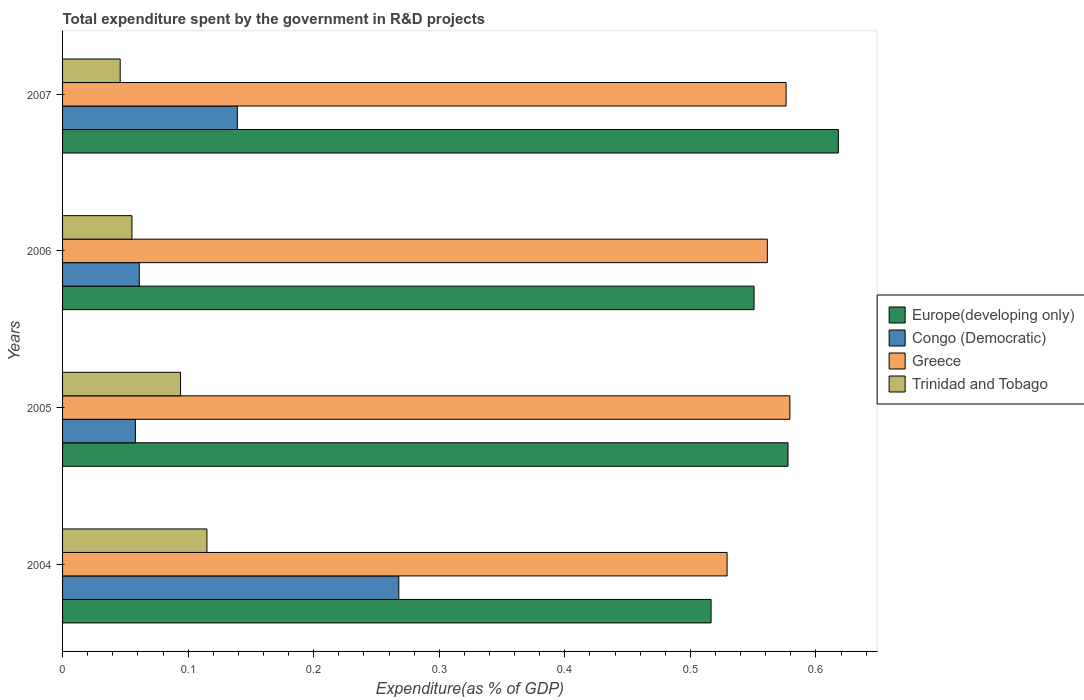How many groups of bars are there?
Make the answer very short. 4. Are the number of bars on each tick of the Y-axis equal?
Your answer should be very brief. Yes. How many bars are there on the 3rd tick from the top?
Make the answer very short. 4. What is the label of the 4th group of bars from the top?
Make the answer very short. 2004. In how many cases, is the number of bars for a given year not equal to the number of legend labels?
Keep it short and to the point. 0. What is the total expenditure spent by the government in R&D projects in Europe(developing only) in 2006?
Your answer should be very brief. 0.55. Across all years, what is the maximum total expenditure spent by the government in R&D projects in Europe(developing only)?
Provide a succinct answer. 0.62. Across all years, what is the minimum total expenditure spent by the government in R&D projects in Trinidad and Tobago?
Offer a very short reply. 0.05. In which year was the total expenditure spent by the government in R&D projects in Trinidad and Tobago maximum?
Ensure brevity in your answer.  2004. What is the total total expenditure spent by the government in R&D projects in Trinidad and Tobago in the graph?
Give a very brief answer. 0.31. What is the difference between the total expenditure spent by the government in R&D projects in Congo (Democratic) in 2005 and that in 2006?
Offer a very short reply. -0. What is the difference between the total expenditure spent by the government in R&D projects in Congo (Democratic) in 2005 and the total expenditure spent by the government in R&D projects in Europe(developing only) in 2007?
Offer a very short reply. -0.56. What is the average total expenditure spent by the government in R&D projects in Europe(developing only) per year?
Ensure brevity in your answer.  0.57. In the year 2007, what is the difference between the total expenditure spent by the government in R&D projects in Trinidad and Tobago and total expenditure spent by the government in R&D projects in Greece?
Offer a very short reply. -0.53. In how many years, is the total expenditure spent by the government in R&D projects in Congo (Democratic) greater than 0.1 %?
Ensure brevity in your answer.  2. What is the ratio of the total expenditure spent by the government in R&D projects in Europe(developing only) in 2006 to that in 2007?
Keep it short and to the point. 0.89. Is the total expenditure spent by the government in R&D projects in Greece in 2004 less than that in 2007?
Your answer should be very brief. Yes. Is the difference between the total expenditure spent by the government in R&D projects in Trinidad and Tobago in 2004 and 2007 greater than the difference between the total expenditure spent by the government in R&D projects in Greece in 2004 and 2007?
Your answer should be compact. Yes. What is the difference between the highest and the second highest total expenditure spent by the government in R&D projects in Europe(developing only)?
Ensure brevity in your answer.  0.04. What is the difference between the highest and the lowest total expenditure spent by the government in R&D projects in Congo (Democratic)?
Offer a terse response. 0.21. In how many years, is the total expenditure spent by the government in R&D projects in Greece greater than the average total expenditure spent by the government in R&D projects in Greece taken over all years?
Give a very brief answer. 2. Is it the case that in every year, the sum of the total expenditure spent by the government in R&D projects in Congo (Democratic) and total expenditure spent by the government in R&D projects in Greece is greater than the total expenditure spent by the government in R&D projects in Trinidad and Tobago?
Make the answer very short. Yes. How many bars are there?
Your answer should be very brief. 16. How many years are there in the graph?
Provide a succinct answer. 4. What is the difference between two consecutive major ticks on the X-axis?
Offer a terse response. 0.1. Are the values on the major ticks of X-axis written in scientific E-notation?
Provide a short and direct response. No. Does the graph contain any zero values?
Offer a very short reply. No. Does the graph contain grids?
Offer a terse response. No. Where does the legend appear in the graph?
Make the answer very short. Center right. What is the title of the graph?
Offer a very short reply. Total expenditure spent by the government in R&D projects. What is the label or title of the X-axis?
Give a very brief answer. Expenditure(as % of GDP). What is the label or title of the Y-axis?
Your answer should be compact. Years. What is the Expenditure(as % of GDP) in Europe(developing only) in 2004?
Provide a succinct answer. 0.52. What is the Expenditure(as % of GDP) in Congo (Democratic) in 2004?
Provide a succinct answer. 0.27. What is the Expenditure(as % of GDP) of Greece in 2004?
Make the answer very short. 0.53. What is the Expenditure(as % of GDP) of Trinidad and Tobago in 2004?
Provide a succinct answer. 0.11. What is the Expenditure(as % of GDP) in Europe(developing only) in 2005?
Your answer should be very brief. 0.58. What is the Expenditure(as % of GDP) in Congo (Democratic) in 2005?
Provide a succinct answer. 0.06. What is the Expenditure(as % of GDP) of Greece in 2005?
Provide a short and direct response. 0.58. What is the Expenditure(as % of GDP) of Trinidad and Tobago in 2005?
Ensure brevity in your answer.  0.09. What is the Expenditure(as % of GDP) of Europe(developing only) in 2006?
Give a very brief answer. 0.55. What is the Expenditure(as % of GDP) of Congo (Democratic) in 2006?
Your answer should be compact. 0.06. What is the Expenditure(as % of GDP) of Greece in 2006?
Keep it short and to the point. 0.56. What is the Expenditure(as % of GDP) in Trinidad and Tobago in 2006?
Offer a very short reply. 0.06. What is the Expenditure(as % of GDP) of Europe(developing only) in 2007?
Keep it short and to the point. 0.62. What is the Expenditure(as % of GDP) in Congo (Democratic) in 2007?
Your response must be concise. 0.14. What is the Expenditure(as % of GDP) of Greece in 2007?
Your answer should be compact. 0.58. What is the Expenditure(as % of GDP) in Trinidad and Tobago in 2007?
Your answer should be very brief. 0.05. Across all years, what is the maximum Expenditure(as % of GDP) in Europe(developing only)?
Your answer should be compact. 0.62. Across all years, what is the maximum Expenditure(as % of GDP) in Congo (Democratic)?
Offer a very short reply. 0.27. Across all years, what is the maximum Expenditure(as % of GDP) of Greece?
Offer a terse response. 0.58. Across all years, what is the maximum Expenditure(as % of GDP) in Trinidad and Tobago?
Keep it short and to the point. 0.11. Across all years, what is the minimum Expenditure(as % of GDP) of Europe(developing only)?
Your answer should be compact. 0.52. Across all years, what is the minimum Expenditure(as % of GDP) in Congo (Democratic)?
Provide a succinct answer. 0.06. Across all years, what is the minimum Expenditure(as % of GDP) in Greece?
Your answer should be compact. 0.53. Across all years, what is the minimum Expenditure(as % of GDP) of Trinidad and Tobago?
Offer a very short reply. 0.05. What is the total Expenditure(as % of GDP) in Europe(developing only) in the graph?
Your answer should be compact. 2.26. What is the total Expenditure(as % of GDP) in Congo (Democratic) in the graph?
Keep it short and to the point. 0.53. What is the total Expenditure(as % of GDP) of Greece in the graph?
Offer a terse response. 2.25. What is the total Expenditure(as % of GDP) in Trinidad and Tobago in the graph?
Your answer should be very brief. 0.31. What is the difference between the Expenditure(as % of GDP) in Europe(developing only) in 2004 and that in 2005?
Provide a succinct answer. -0.06. What is the difference between the Expenditure(as % of GDP) in Congo (Democratic) in 2004 and that in 2005?
Keep it short and to the point. 0.21. What is the difference between the Expenditure(as % of GDP) in Trinidad and Tobago in 2004 and that in 2005?
Your response must be concise. 0.02. What is the difference between the Expenditure(as % of GDP) in Europe(developing only) in 2004 and that in 2006?
Keep it short and to the point. -0.03. What is the difference between the Expenditure(as % of GDP) in Congo (Democratic) in 2004 and that in 2006?
Make the answer very short. 0.21. What is the difference between the Expenditure(as % of GDP) of Greece in 2004 and that in 2006?
Offer a terse response. -0.03. What is the difference between the Expenditure(as % of GDP) of Trinidad and Tobago in 2004 and that in 2006?
Make the answer very short. 0.06. What is the difference between the Expenditure(as % of GDP) of Europe(developing only) in 2004 and that in 2007?
Keep it short and to the point. -0.1. What is the difference between the Expenditure(as % of GDP) in Congo (Democratic) in 2004 and that in 2007?
Your response must be concise. 0.13. What is the difference between the Expenditure(as % of GDP) in Greece in 2004 and that in 2007?
Offer a very short reply. -0.05. What is the difference between the Expenditure(as % of GDP) of Trinidad and Tobago in 2004 and that in 2007?
Make the answer very short. 0.07. What is the difference between the Expenditure(as % of GDP) in Europe(developing only) in 2005 and that in 2006?
Give a very brief answer. 0.03. What is the difference between the Expenditure(as % of GDP) of Congo (Democratic) in 2005 and that in 2006?
Your answer should be very brief. -0. What is the difference between the Expenditure(as % of GDP) in Greece in 2005 and that in 2006?
Keep it short and to the point. 0.02. What is the difference between the Expenditure(as % of GDP) of Trinidad and Tobago in 2005 and that in 2006?
Your response must be concise. 0.04. What is the difference between the Expenditure(as % of GDP) of Europe(developing only) in 2005 and that in 2007?
Your answer should be compact. -0.04. What is the difference between the Expenditure(as % of GDP) in Congo (Democratic) in 2005 and that in 2007?
Give a very brief answer. -0.08. What is the difference between the Expenditure(as % of GDP) in Greece in 2005 and that in 2007?
Offer a terse response. 0. What is the difference between the Expenditure(as % of GDP) in Trinidad and Tobago in 2005 and that in 2007?
Your response must be concise. 0.05. What is the difference between the Expenditure(as % of GDP) of Europe(developing only) in 2006 and that in 2007?
Your response must be concise. -0.07. What is the difference between the Expenditure(as % of GDP) in Congo (Democratic) in 2006 and that in 2007?
Provide a succinct answer. -0.08. What is the difference between the Expenditure(as % of GDP) of Greece in 2006 and that in 2007?
Give a very brief answer. -0.01. What is the difference between the Expenditure(as % of GDP) of Trinidad and Tobago in 2006 and that in 2007?
Offer a terse response. 0.01. What is the difference between the Expenditure(as % of GDP) of Europe(developing only) in 2004 and the Expenditure(as % of GDP) of Congo (Democratic) in 2005?
Keep it short and to the point. 0.46. What is the difference between the Expenditure(as % of GDP) in Europe(developing only) in 2004 and the Expenditure(as % of GDP) in Greece in 2005?
Make the answer very short. -0.06. What is the difference between the Expenditure(as % of GDP) of Europe(developing only) in 2004 and the Expenditure(as % of GDP) of Trinidad and Tobago in 2005?
Give a very brief answer. 0.42. What is the difference between the Expenditure(as % of GDP) of Congo (Democratic) in 2004 and the Expenditure(as % of GDP) of Greece in 2005?
Keep it short and to the point. -0.31. What is the difference between the Expenditure(as % of GDP) of Congo (Democratic) in 2004 and the Expenditure(as % of GDP) of Trinidad and Tobago in 2005?
Offer a very short reply. 0.17. What is the difference between the Expenditure(as % of GDP) in Greece in 2004 and the Expenditure(as % of GDP) in Trinidad and Tobago in 2005?
Your response must be concise. 0.44. What is the difference between the Expenditure(as % of GDP) in Europe(developing only) in 2004 and the Expenditure(as % of GDP) in Congo (Democratic) in 2006?
Provide a short and direct response. 0.46. What is the difference between the Expenditure(as % of GDP) of Europe(developing only) in 2004 and the Expenditure(as % of GDP) of Greece in 2006?
Your response must be concise. -0.04. What is the difference between the Expenditure(as % of GDP) of Europe(developing only) in 2004 and the Expenditure(as % of GDP) of Trinidad and Tobago in 2006?
Your answer should be compact. 0.46. What is the difference between the Expenditure(as % of GDP) of Congo (Democratic) in 2004 and the Expenditure(as % of GDP) of Greece in 2006?
Keep it short and to the point. -0.29. What is the difference between the Expenditure(as % of GDP) of Congo (Democratic) in 2004 and the Expenditure(as % of GDP) of Trinidad and Tobago in 2006?
Ensure brevity in your answer.  0.21. What is the difference between the Expenditure(as % of GDP) in Greece in 2004 and the Expenditure(as % of GDP) in Trinidad and Tobago in 2006?
Ensure brevity in your answer.  0.47. What is the difference between the Expenditure(as % of GDP) of Europe(developing only) in 2004 and the Expenditure(as % of GDP) of Congo (Democratic) in 2007?
Make the answer very short. 0.38. What is the difference between the Expenditure(as % of GDP) of Europe(developing only) in 2004 and the Expenditure(as % of GDP) of Greece in 2007?
Your answer should be very brief. -0.06. What is the difference between the Expenditure(as % of GDP) in Europe(developing only) in 2004 and the Expenditure(as % of GDP) in Trinidad and Tobago in 2007?
Your answer should be compact. 0.47. What is the difference between the Expenditure(as % of GDP) in Congo (Democratic) in 2004 and the Expenditure(as % of GDP) in Greece in 2007?
Your answer should be very brief. -0.31. What is the difference between the Expenditure(as % of GDP) of Congo (Democratic) in 2004 and the Expenditure(as % of GDP) of Trinidad and Tobago in 2007?
Your answer should be compact. 0.22. What is the difference between the Expenditure(as % of GDP) in Greece in 2004 and the Expenditure(as % of GDP) in Trinidad and Tobago in 2007?
Keep it short and to the point. 0.48. What is the difference between the Expenditure(as % of GDP) in Europe(developing only) in 2005 and the Expenditure(as % of GDP) in Congo (Democratic) in 2006?
Provide a short and direct response. 0.52. What is the difference between the Expenditure(as % of GDP) of Europe(developing only) in 2005 and the Expenditure(as % of GDP) of Greece in 2006?
Provide a short and direct response. 0.02. What is the difference between the Expenditure(as % of GDP) in Europe(developing only) in 2005 and the Expenditure(as % of GDP) in Trinidad and Tobago in 2006?
Offer a very short reply. 0.52. What is the difference between the Expenditure(as % of GDP) in Congo (Democratic) in 2005 and the Expenditure(as % of GDP) in Greece in 2006?
Offer a terse response. -0.5. What is the difference between the Expenditure(as % of GDP) in Congo (Democratic) in 2005 and the Expenditure(as % of GDP) in Trinidad and Tobago in 2006?
Your answer should be very brief. 0. What is the difference between the Expenditure(as % of GDP) in Greece in 2005 and the Expenditure(as % of GDP) in Trinidad and Tobago in 2006?
Your response must be concise. 0.52. What is the difference between the Expenditure(as % of GDP) of Europe(developing only) in 2005 and the Expenditure(as % of GDP) of Congo (Democratic) in 2007?
Provide a succinct answer. 0.44. What is the difference between the Expenditure(as % of GDP) in Europe(developing only) in 2005 and the Expenditure(as % of GDP) in Greece in 2007?
Your answer should be compact. 0. What is the difference between the Expenditure(as % of GDP) in Europe(developing only) in 2005 and the Expenditure(as % of GDP) in Trinidad and Tobago in 2007?
Offer a very short reply. 0.53. What is the difference between the Expenditure(as % of GDP) in Congo (Democratic) in 2005 and the Expenditure(as % of GDP) in Greece in 2007?
Offer a very short reply. -0.52. What is the difference between the Expenditure(as % of GDP) of Congo (Democratic) in 2005 and the Expenditure(as % of GDP) of Trinidad and Tobago in 2007?
Ensure brevity in your answer.  0.01. What is the difference between the Expenditure(as % of GDP) of Greece in 2005 and the Expenditure(as % of GDP) of Trinidad and Tobago in 2007?
Your answer should be very brief. 0.53. What is the difference between the Expenditure(as % of GDP) in Europe(developing only) in 2006 and the Expenditure(as % of GDP) in Congo (Democratic) in 2007?
Your answer should be compact. 0.41. What is the difference between the Expenditure(as % of GDP) in Europe(developing only) in 2006 and the Expenditure(as % of GDP) in Greece in 2007?
Keep it short and to the point. -0.03. What is the difference between the Expenditure(as % of GDP) of Europe(developing only) in 2006 and the Expenditure(as % of GDP) of Trinidad and Tobago in 2007?
Your answer should be very brief. 0.5. What is the difference between the Expenditure(as % of GDP) of Congo (Democratic) in 2006 and the Expenditure(as % of GDP) of Greece in 2007?
Keep it short and to the point. -0.52. What is the difference between the Expenditure(as % of GDP) of Congo (Democratic) in 2006 and the Expenditure(as % of GDP) of Trinidad and Tobago in 2007?
Offer a very short reply. 0.02. What is the difference between the Expenditure(as % of GDP) in Greece in 2006 and the Expenditure(as % of GDP) in Trinidad and Tobago in 2007?
Ensure brevity in your answer.  0.52. What is the average Expenditure(as % of GDP) of Europe(developing only) per year?
Ensure brevity in your answer.  0.57. What is the average Expenditure(as % of GDP) in Congo (Democratic) per year?
Offer a very short reply. 0.13. What is the average Expenditure(as % of GDP) of Greece per year?
Provide a succinct answer. 0.56. What is the average Expenditure(as % of GDP) in Trinidad and Tobago per year?
Offer a very short reply. 0.08. In the year 2004, what is the difference between the Expenditure(as % of GDP) in Europe(developing only) and Expenditure(as % of GDP) in Congo (Democratic)?
Offer a terse response. 0.25. In the year 2004, what is the difference between the Expenditure(as % of GDP) in Europe(developing only) and Expenditure(as % of GDP) in Greece?
Your response must be concise. -0.01. In the year 2004, what is the difference between the Expenditure(as % of GDP) of Europe(developing only) and Expenditure(as % of GDP) of Trinidad and Tobago?
Make the answer very short. 0.4. In the year 2004, what is the difference between the Expenditure(as % of GDP) of Congo (Democratic) and Expenditure(as % of GDP) of Greece?
Provide a succinct answer. -0.26. In the year 2004, what is the difference between the Expenditure(as % of GDP) of Congo (Democratic) and Expenditure(as % of GDP) of Trinidad and Tobago?
Make the answer very short. 0.15. In the year 2004, what is the difference between the Expenditure(as % of GDP) of Greece and Expenditure(as % of GDP) of Trinidad and Tobago?
Your answer should be very brief. 0.41. In the year 2005, what is the difference between the Expenditure(as % of GDP) in Europe(developing only) and Expenditure(as % of GDP) in Congo (Democratic)?
Give a very brief answer. 0.52. In the year 2005, what is the difference between the Expenditure(as % of GDP) in Europe(developing only) and Expenditure(as % of GDP) in Greece?
Provide a short and direct response. -0. In the year 2005, what is the difference between the Expenditure(as % of GDP) in Europe(developing only) and Expenditure(as % of GDP) in Trinidad and Tobago?
Offer a terse response. 0.48. In the year 2005, what is the difference between the Expenditure(as % of GDP) of Congo (Democratic) and Expenditure(as % of GDP) of Greece?
Give a very brief answer. -0.52. In the year 2005, what is the difference between the Expenditure(as % of GDP) in Congo (Democratic) and Expenditure(as % of GDP) in Trinidad and Tobago?
Make the answer very short. -0.04. In the year 2005, what is the difference between the Expenditure(as % of GDP) in Greece and Expenditure(as % of GDP) in Trinidad and Tobago?
Offer a very short reply. 0.49. In the year 2006, what is the difference between the Expenditure(as % of GDP) in Europe(developing only) and Expenditure(as % of GDP) in Congo (Democratic)?
Make the answer very short. 0.49. In the year 2006, what is the difference between the Expenditure(as % of GDP) in Europe(developing only) and Expenditure(as % of GDP) in Greece?
Offer a terse response. -0.01. In the year 2006, what is the difference between the Expenditure(as % of GDP) in Europe(developing only) and Expenditure(as % of GDP) in Trinidad and Tobago?
Your answer should be compact. 0.5. In the year 2006, what is the difference between the Expenditure(as % of GDP) in Congo (Democratic) and Expenditure(as % of GDP) in Greece?
Provide a succinct answer. -0.5. In the year 2006, what is the difference between the Expenditure(as % of GDP) in Congo (Democratic) and Expenditure(as % of GDP) in Trinidad and Tobago?
Provide a short and direct response. 0.01. In the year 2006, what is the difference between the Expenditure(as % of GDP) of Greece and Expenditure(as % of GDP) of Trinidad and Tobago?
Provide a succinct answer. 0.51. In the year 2007, what is the difference between the Expenditure(as % of GDP) of Europe(developing only) and Expenditure(as % of GDP) of Congo (Democratic)?
Keep it short and to the point. 0.48. In the year 2007, what is the difference between the Expenditure(as % of GDP) of Europe(developing only) and Expenditure(as % of GDP) of Greece?
Provide a short and direct response. 0.04. In the year 2007, what is the difference between the Expenditure(as % of GDP) of Europe(developing only) and Expenditure(as % of GDP) of Trinidad and Tobago?
Offer a very short reply. 0.57. In the year 2007, what is the difference between the Expenditure(as % of GDP) of Congo (Democratic) and Expenditure(as % of GDP) of Greece?
Give a very brief answer. -0.44. In the year 2007, what is the difference between the Expenditure(as % of GDP) in Congo (Democratic) and Expenditure(as % of GDP) in Trinidad and Tobago?
Provide a succinct answer. 0.09. In the year 2007, what is the difference between the Expenditure(as % of GDP) of Greece and Expenditure(as % of GDP) of Trinidad and Tobago?
Keep it short and to the point. 0.53. What is the ratio of the Expenditure(as % of GDP) of Europe(developing only) in 2004 to that in 2005?
Offer a terse response. 0.89. What is the ratio of the Expenditure(as % of GDP) of Congo (Democratic) in 2004 to that in 2005?
Provide a succinct answer. 4.62. What is the ratio of the Expenditure(as % of GDP) in Greece in 2004 to that in 2005?
Your response must be concise. 0.91. What is the ratio of the Expenditure(as % of GDP) in Trinidad and Tobago in 2004 to that in 2005?
Your answer should be compact. 1.22. What is the ratio of the Expenditure(as % of GDP) in Europe(developing only) in 2004 to that in 2006?
Your answer should be compact. 0.94. What is the ratio of the Expenditure(as % of GDP) of Congo (Democratic) in 2004 to that in 2006?
Your answer should be very brief. 4.38. What is the ratio of the Expenditure(as % of GDP) in Greece in 2004 to that in 2006?
Offer a very short reply. 0.94. What is the ratio of the Expenditure(as % of GDP) of Trinidad and Tobago in 2004 to that in 2006?
Make the answer very short. 2.08. What is the ratio of the Expenditure(as % of GDP) in Europe(developing only) in 2004 to that in 2007?
Offer a terse response. 0.84. What is the ratio of the Expenditure(as % of GDP) of Congo (Democratic) in 2004 to that in 2007?
Your answer should be compact. 1.92. What is the ratio of the Expenditure(as % of GDP) in Greece in 2004 to that in 2007?
Keep it short and to the point. 0.92. What is the ratio of the Expenditure(as % of GDP) of Trinidad and Tobago in 2004 to that in 2007?
Your response must be concise. 2.51. What is the ratio of the Expenditure(as % of GDP) of Europe(developing only) in 2005 to that in 2006?
Your answer should be compact. 1.05. What is the ratio of the Expenditure(as % of GDP) of Congo (Democratic) in 2005 to that in 2006?
Offer a terse response. 0.95. What is the ratio of the Expenditure(as % of GDP) of Greece in 2005 to that in 2006?
Your answer should be compact. 1.03. What is the ratio of the Expenditure(as % of GDP) of Trinidad and Tobago in 2005 to that in 2006?
Your response must be concise. 1.7. What is the ratio of the Expenditure(as % of GDP) of Europe(developing only) in 2005 to that in 2007?
Provide a short and direct response. 0.94. What is the ratio of the Expenditure(as % of GDP) in Congo (Democratic) in 2005 to that in 2007?
Your answer should be very brief. 0.42. What is the ratio of the Expenditure(as % of GDP) of Trinidad and Tobago in 2005 to that in 2007?
Your answer should be very brief. 2.05. What is the ratio of the Expenditure(as % of GDP) of Europe(developing only) in 2006 to that in 2007?
Offer a terse response. 0.89. What is the ratio of the Expenditure(as % of GDP) in Congo (Democratic) in 2006 to that in 2007?
Your response must be concise. 0.44. What is the ratio of the Expenditure(as % of GDP) of Greece in 2006 to that in 2007?
Your answer should be compact. 0.97. What is the ratio of the Expenditure(as % of GDP) of Trinidad and Tobago in 2006 to that in 2007?
Keep it short and to the point. 1.2. What is the difference between the highest and the second highest Expenditure(as % of GDP) in Europe(developing only)?
Keep it short and to the point. 0.04. What is the difference between the highest and the second highest Expenditure(as % of GDP) in Congo (Democratic)?
Provide a short and direct response. 0.13. What is the difference between the highest and the second highest Expenditure(as % of GDP) in Greece?
Keep it short and to the point. 0. What is the difference between the highest and the second highest Expenditure(as % of GDP) of Trinidad and Tobago?
Ensure brevity in your answer.  0.02. What is the difference between the highest and the lowest Expenditure(as % of GDP) in Europe(developing only)?
Keep it short and to the point. 0.1. What is the difference between the highest and the lowest Expenditure(as % of GDP) in Congo (Democratic)?
Your response must be concise. 0.21. What is the difference between the highest and the lowest Expenditure(as % of GDP) in Trinidad and Tobago?
Provide a short and direct response. 0.07. 